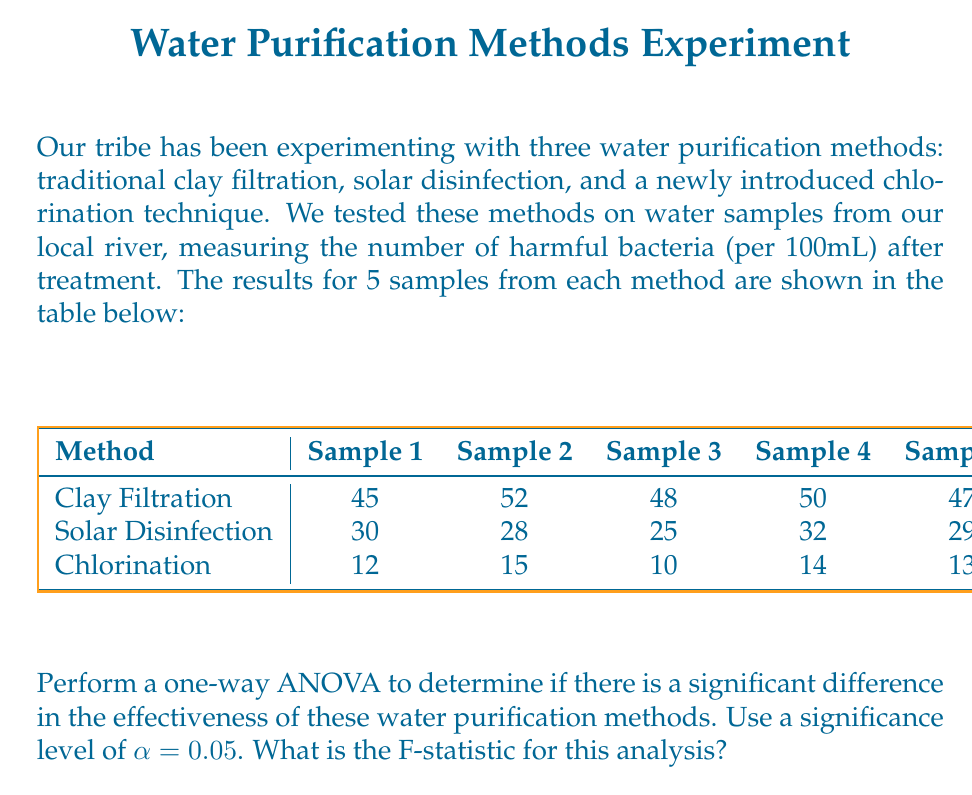What is the answer to this math problem? To perform a one-way ANOVA, we need to follow these steps:

1) Calculate the mean for each group and the overall mean:
   Clay Filtration: $\bar{x}_1 = (45 + 52 + 48 + 50 + 47) / 5 = 48.4$
   Solar Disinfection: $\bar{x}_2 = (30 + 28 + 25 + 32 + 29) / 5 = 28.8$
   Chlorination: $\bar{x}_3 = (12 + 15 + 10 + 14 + 13) / 5 = 12.8$
   Overall mean: $\bar{x} = (48.4 + 28.8 + 12.8) / 3 = 30$

2) Calculate the Sum of Squares Between groups (SSB):
   $$SSB = \sum_{i=1}^{k} n_i(\bar{x}_i - \bar{x})^2$$
   where $k$ is the number of groups and $n_i$ is the number of samples in each group.
   
   $$SSB = 5(48.4 - 30)^2 + 5(28.8 - 30)^2 + 5(12.8 - 30)^2 = 3172.93$$

3) Calculate the Sum of Squares Within groups (SSW):
   $$SSW = \sum_{i=1}^{k} \sum_{j=1}^{n_i} (x_{ij} - \bar{x}_i)^2$$

   Clay Filtration: $(45-48.4)^2 + (52-48.4)^2 + (48-48.4)^2 + (50-48.4)^2 + (47-48.4)^2 = 30.8$
   Solar Disinfection: $(30-28.8)^2 + (28-28.8)^2 + (25-28.8)^2 + (32-28.8)^2 + (29-28.8)^2 = 30.8$
   Chlorination: $(12-12.8)^2 + (15-12.8)^2 + (10-12.8)^2 + (14-12.8)^2 + (13-12.8)^2 = 14.8$

   $$SSW = 30.8 + 30.8 + 14.8 = 76.4$$

4) Calculate the degrees of freedom:
   Between groups: $df_B = k - 1 = 3 - 1 = 2$
   Within groups: $df_W = N - k = 15 - 3 = 12$
   where $N$ is the total number of samples.

5) Calculate the Mean Square Between (MSB) and Mean Square Within (MSW):
   $$MSB = SSB / df_B = 3172.93 / 2 = 1586.465$$
   $$MSW = SSW / df_W = 76.4 / 12 = 6.367$$

6) Calculate the F-statistic:
   $$F = MSB / MSW = 1586.465 / 6.367 = 249.17$$

Therefore, the F-statistic for this analysis is approximately 249.17.
Answer: 249.17 